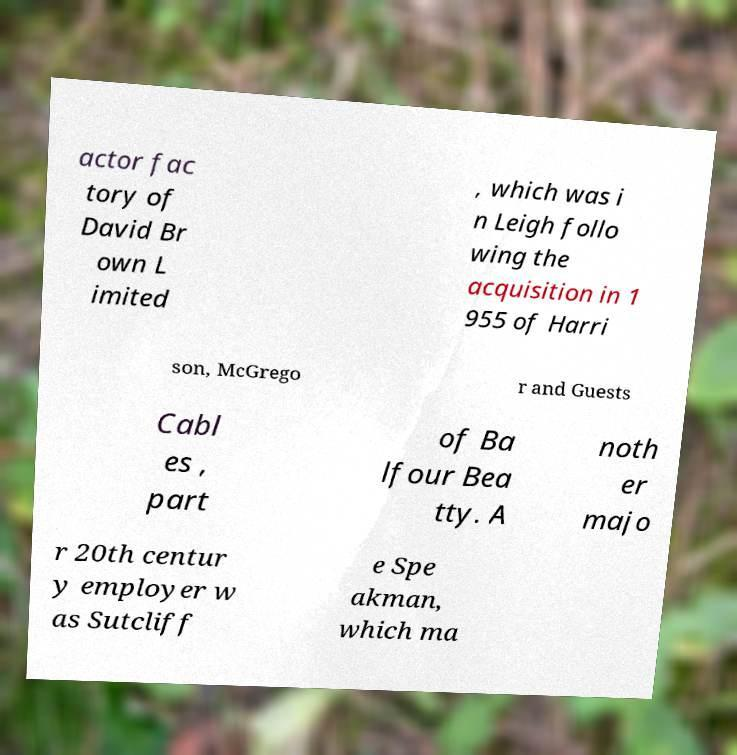Can you accurately transcribe the text from the provided image for me? actor fac tory of David Br own L imited , which was i n Leigh follo wing the acquisition in 1 955 of Harri son, McGrego r and Guests Cabl es , part of Ba lfour Bea tty. A noth er majo r 20th centur y employer w as Sutcliff e Spe akman, which ma 